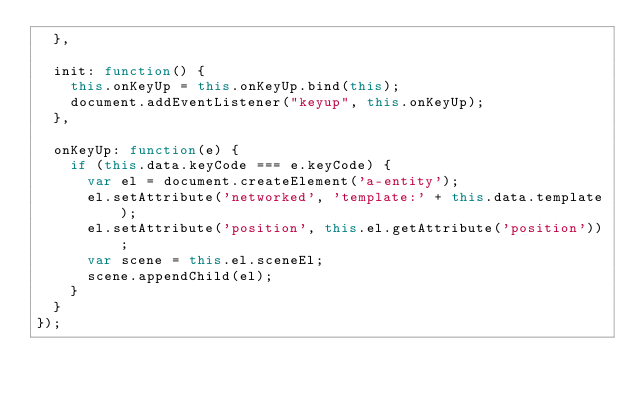<code> <loc_0><loc_0><loc_500><loc_500><_JavaScript_>  },

  init: function() {
    this.onKeyUp = this.onKeyUp.bind(this);
    document.addEventListener("keyup", this.onKeyUp);
  },

  onKeyUp: function(e) {
    if (this.data.keyCode === e.keyCode) {
      var el = document.createElement('a-entity');
      el.setAttribute('networked', 'template:' + this.data.template);
      el.setAttribute('position', this.el.getAttribute('position'));
      var scene = this.el.sceneEl;
      scene.appendChild(el);
    }
  }
});</code> 